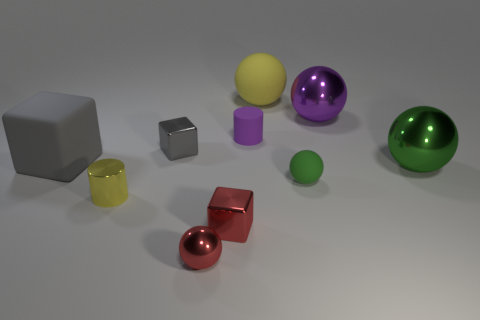Subtract all green metallic balls. How many balls are left? 4 Subtract all red blocks. How many blocks are left? 2 Subtract all cubes. How many objects are left? 7 Subtract all brown spheres. How many red cylinders are left? 0 Subtract all metallic cylinders. Subtract all big gray rubber objects. How many objects are left? 8 Add 4 small red blocks. How many small red blocks are left? 5 Add 2 big green cubes. How many big green cubes exist? 2 Subtract 0 blue cylinders. How many objects are left? 10 Subtract 3 cubes. How many cubes are left? 0 Subtract all gray blocks. Subtract all yellow cylinders. How many blocks are left? 1 